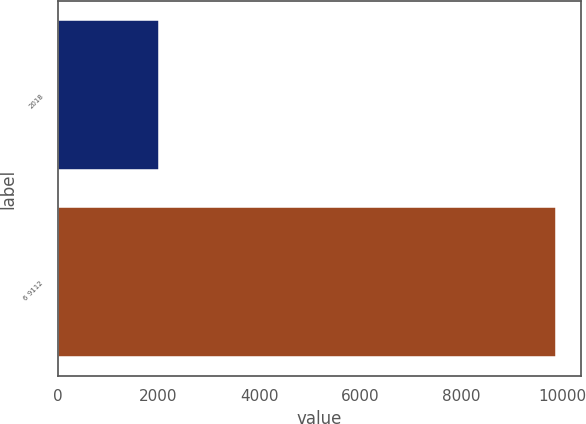Convert chart to OTSL. <chart><loc_0><loc_0><loc_500><loc_500><bar_chart><fcel>2018<fcel>6 9112<nl><fcel>2017<fcel>9882.3<nl></chart> 